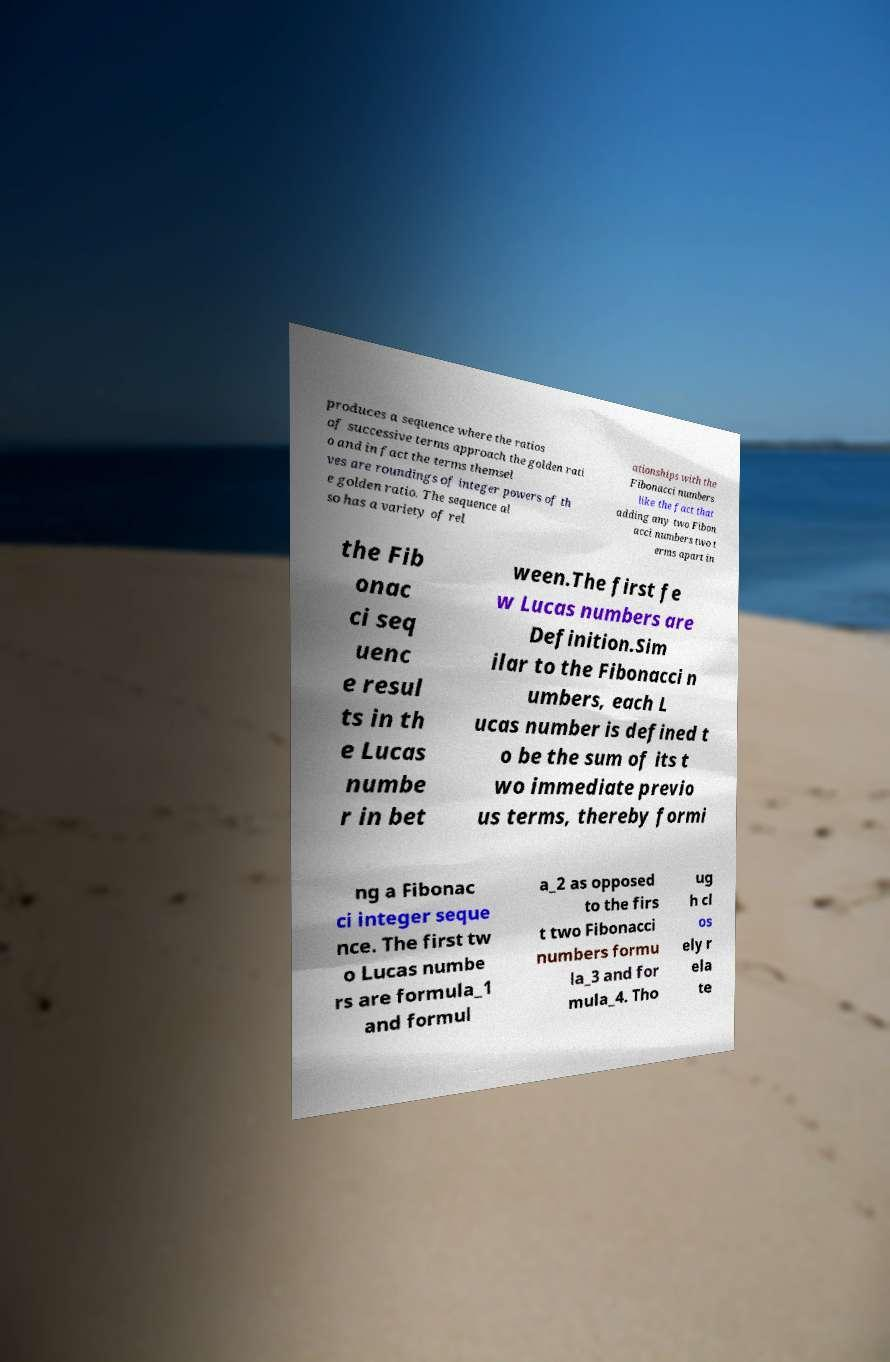There's text embedded in this image that I need extracted. Can you transcribe it verbatim? produces a sequence where the ratios of successive terms approach the golden rati o and in fact the terms themsel ves are roundings of integer powers of th e golden ratio. The sequence al so has a variety of rel ationships with the Fibonacci numbers like the fact that adding any two Fibon acci numbers two t erms apart in the Fib onac ci seq uenc e resul ts in th e Lucas numbe r in bet ween.The first fe w Lucas numbers are Definition.Sim ilar to the Fibonacci n umbers, each L ucas number is defined t o be the sum of its t wo immediate previo us terms, thereby formi ng a Fibonac ci integer seque nce. The first tw o Lucas numbe rs are formula_1 and formul a_2 as opposed to the firs t two Fibonacci numbers formu la_3 and for mula_4. Tho ug h cl os ely r ela te 